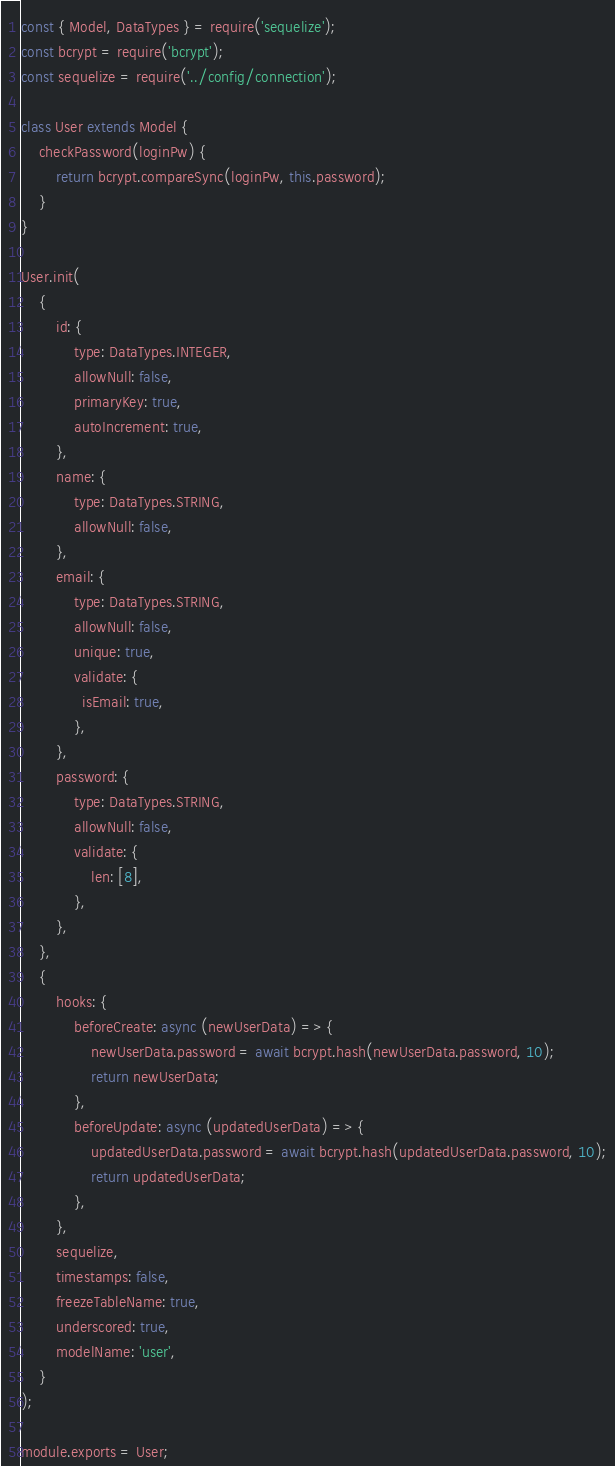<code> <loc_0><loc_0><loc_500><loc_500><_JavaScript_>const { Model, DataTypes } = require('sequelize');
const bcrypt = require('bcrypt');
const sequelize = require('../config/connection');

class User extends Model {
    checkPassword(loginPw) {
        return bcrypt.compareSync(loginPw, this.password);
    }
}

User.init(
    {
        id: {
            type: DataTypes.INTEGER,
            allowNull: false,
            primaryKey: true,
            autoIncrement: true,
        },
        name: {
            type: DataTypes.STRING,
            allowNull: false,
        },
        email: {
            type: DataTypes.STRING,
            allowNull: false,
            unique: true,
            validate: {
              isEmail: true,
            },
        },
        password: {
            type: DataTypes.STRING,
            allowNull: false,
            validate: {
                len: [8],
            },
        },
    },
    {
        hooks: {
            beforeCreate: async (newUserData) => {
                newUserData.password = await bcrypt.hash(newUserData.password, 10);
                return newUserData;
            },
            beforeUpdate: async (updatedUserData) => {
                updatedUserData.password = await bcrypt.hash(updatedUserData.password, 10);
                return updatedUserData;
            },
        },
        sequelize,
        timestamps: false,
        freezeTableName: true,
        underscored: true,
        modelName: 'user',
    }
);

module.exports = User;
</code> 